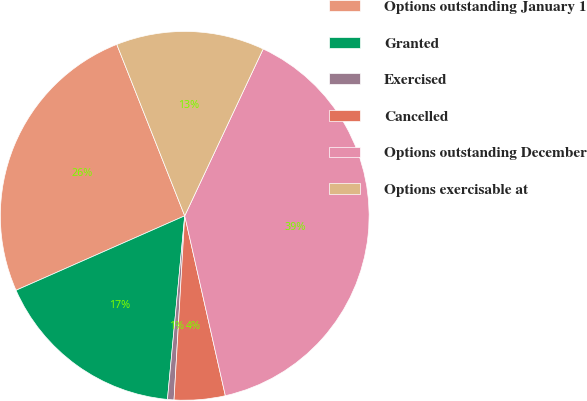Convert chart. <chart><loc_0><loc_0><loc_500><loc_500><pie_chart><fcel>Options outstanding January 1<fcel>Granted<fcel>Exercised<fcel>Cancelled<fcel>Options outstanding December<fcel>Options exercisable at<nl><fcel>25.61%<fcel>16.89%<fcel>0.57%<fcel>4.46%<fcel>39.47%<fcel>13.0%<nl></chart> 